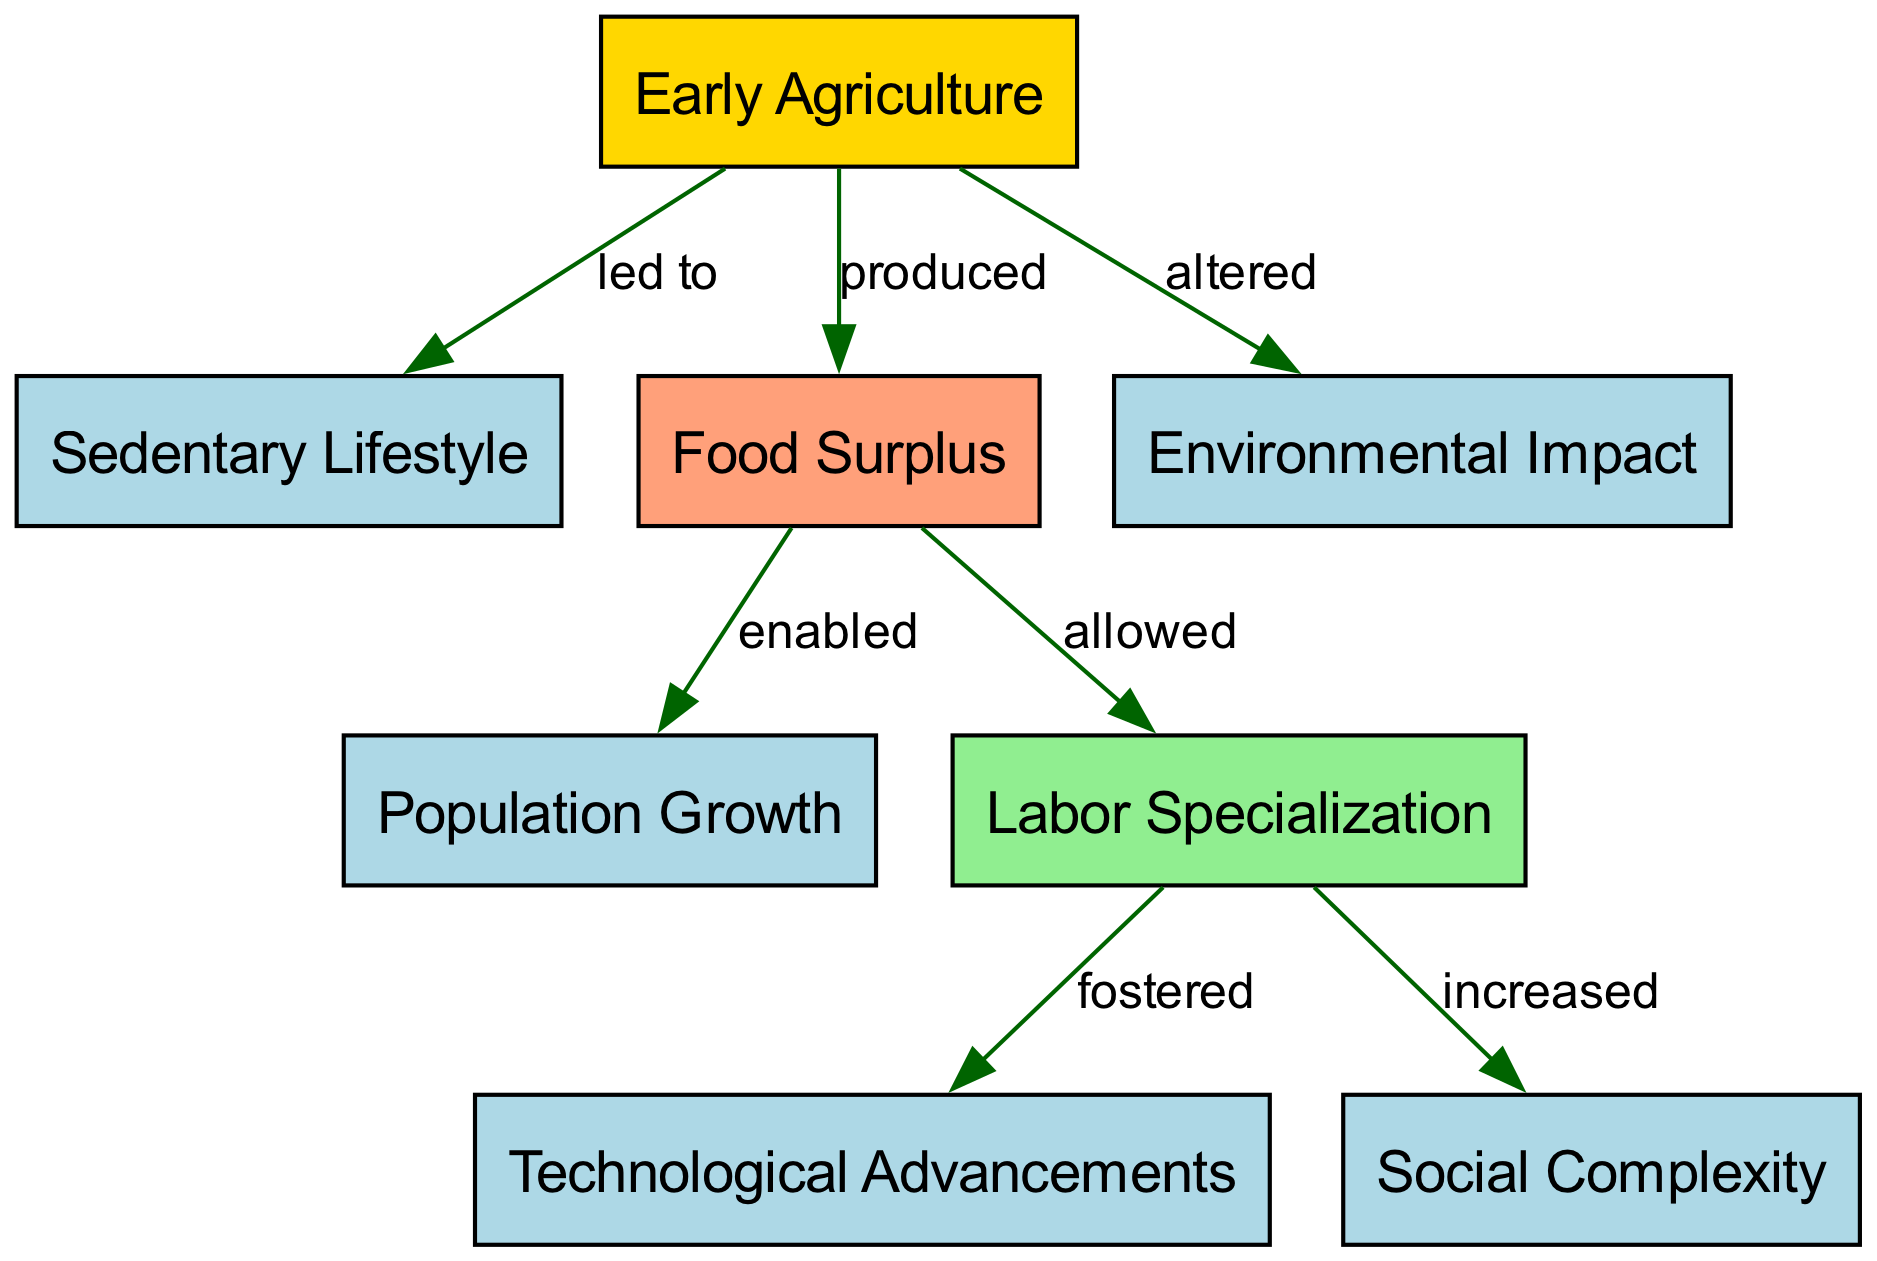What is the central theme of this diagram? The diagram focuses on the concept of "Early Agriculture" and its various effects on human civilization, indicating how agriculture is the starting point for multiple developments in human history.
Answer: Early Agriculture How many nodes are present in the diagram? The diagram contains eight nodes representing different aspects of early agriculture and its impacts, confirming that they encapsulate a broad range of relevant concepts.
Answer: 8 What impact did early agriculture have on human lifestyle? The diagram indicates that early agriculture "led to" a sedentary lifestyle, showing a direct cause-and-effect relationship between the two concepts.
Answer: Sedentary Lifestyle What was the outcome of the food surplus produced by agriculture? According to the diagram, the food surplus "enabled" population growth, highlighting a critical consequence of increased agricultural production.
Answer: Population Growth How did labor specialization relate to technological advancements? The diagram illustrates that labor specialization "fostered" technological advancements, suggesting that as people specialized, they were able to create and improve technologies more effectively.
Answer: Fostered What effect did early agriculture have on the environment? The diagram states that agriculture "altered" the environment, pointing to how human agricultural practices transformed the natural surroundings in which they lived.
Answer: Altered What increased as a result of labor specialization? The diagram shows that labor specialization "increased" social complexity, indicating that as tasks became specialized, societal structures became more intricate.
Answer: Social Complexity What does food surplus allow in terms of human activity? The diagram indicates that a food surplus "allowed" labor specialization, signifying that with enough food, not everyone needed to focus on subsistence, paving the way for different roles.
Answer: Allowed What connection exists between surplus food and population? The diagram explicitly expresses that food surplus "enabled" population growth, which indicates a direct link between food availability and population increase in early human societies.
Answer: Enabled 